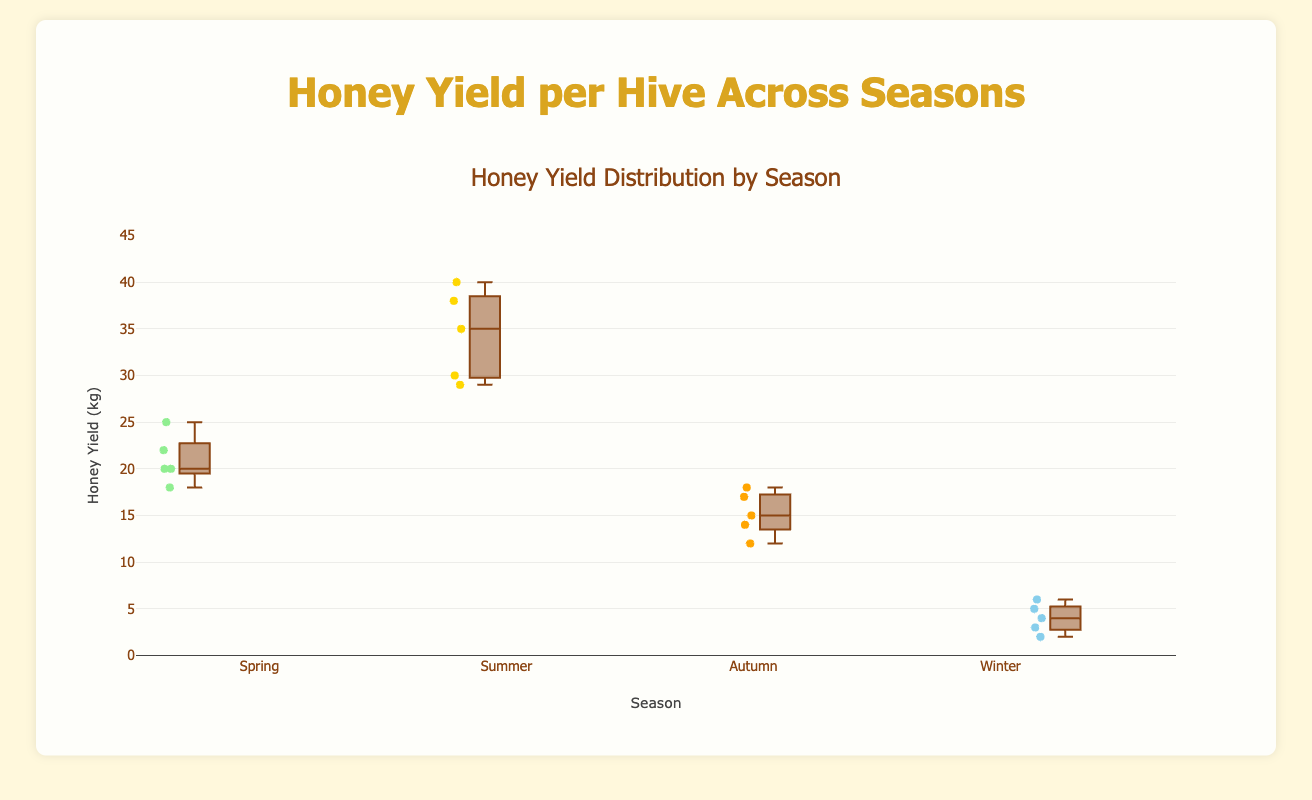What is the title of the box plot? The title of the box plot is located at the top of the figure. It provides a brief description of what the plot represents.
Answer: Honey Yield Distribution by Season What is the range of honey yield values displayed on the y-axis? The range of honey yield values can be observed on the y-axis, which shows the minimum and maximum values it covers.
Answer: 0 to 45 kg How many seasons are compared in this box plot? The number of different seasons can be identified by counting the distinct labels on the x-axis.
Answer: Four Which season has the highest median honey yield? The median honey yield for each season is represented by the line inside each box. By comparing these lines, we can identify the one with the highest position.
Answer: Summer Is the variation in honey yield higher in Summer or Winter? The variation in honey yield is indicated by the interquartile range (IQR), which is the length of the box. By comparing the IQRs of Summer and Winter, we can determine which has higher variation.
Answer: Summer What is the median honey yield for Spring? The median honey yield for Spring can be found by locating the line within the box for the Spring season.
Answer: Approximately 20 kg Which season has the lowest minimum honey yield? The minimum honey yield for each season is represented by the lower whisker of each box plot. The season with the lowest position of the lower whisker indicates the lowest minimum yield.
Answer: Winter How does the maximum honey yield in Autumn compare to that in Spring? The maximum honey yield for each season is represented by the upper whisker of the box plot. By comparing the positions of the upper whiskers for Autumn and Spring, we can see the difference in yields.
Answer: The maximum in Spring is higher Are there any outliers in the Autumn season? Outliers in a box plot are typically indicated by points that fall outside the whiskers. Checking for such points in the Autumn season will answer this question.
Answer: No What is the interquartile range (IQR) for the Summer season? The IQR is the distance between the first quartile (Q1) and the third quartile (Q3). For the Summer season, locate Q1 and Q3 and subtract Q1 from Q3. Q1 is around 29 and Q3 is around 38.
Answer: 9 kg 